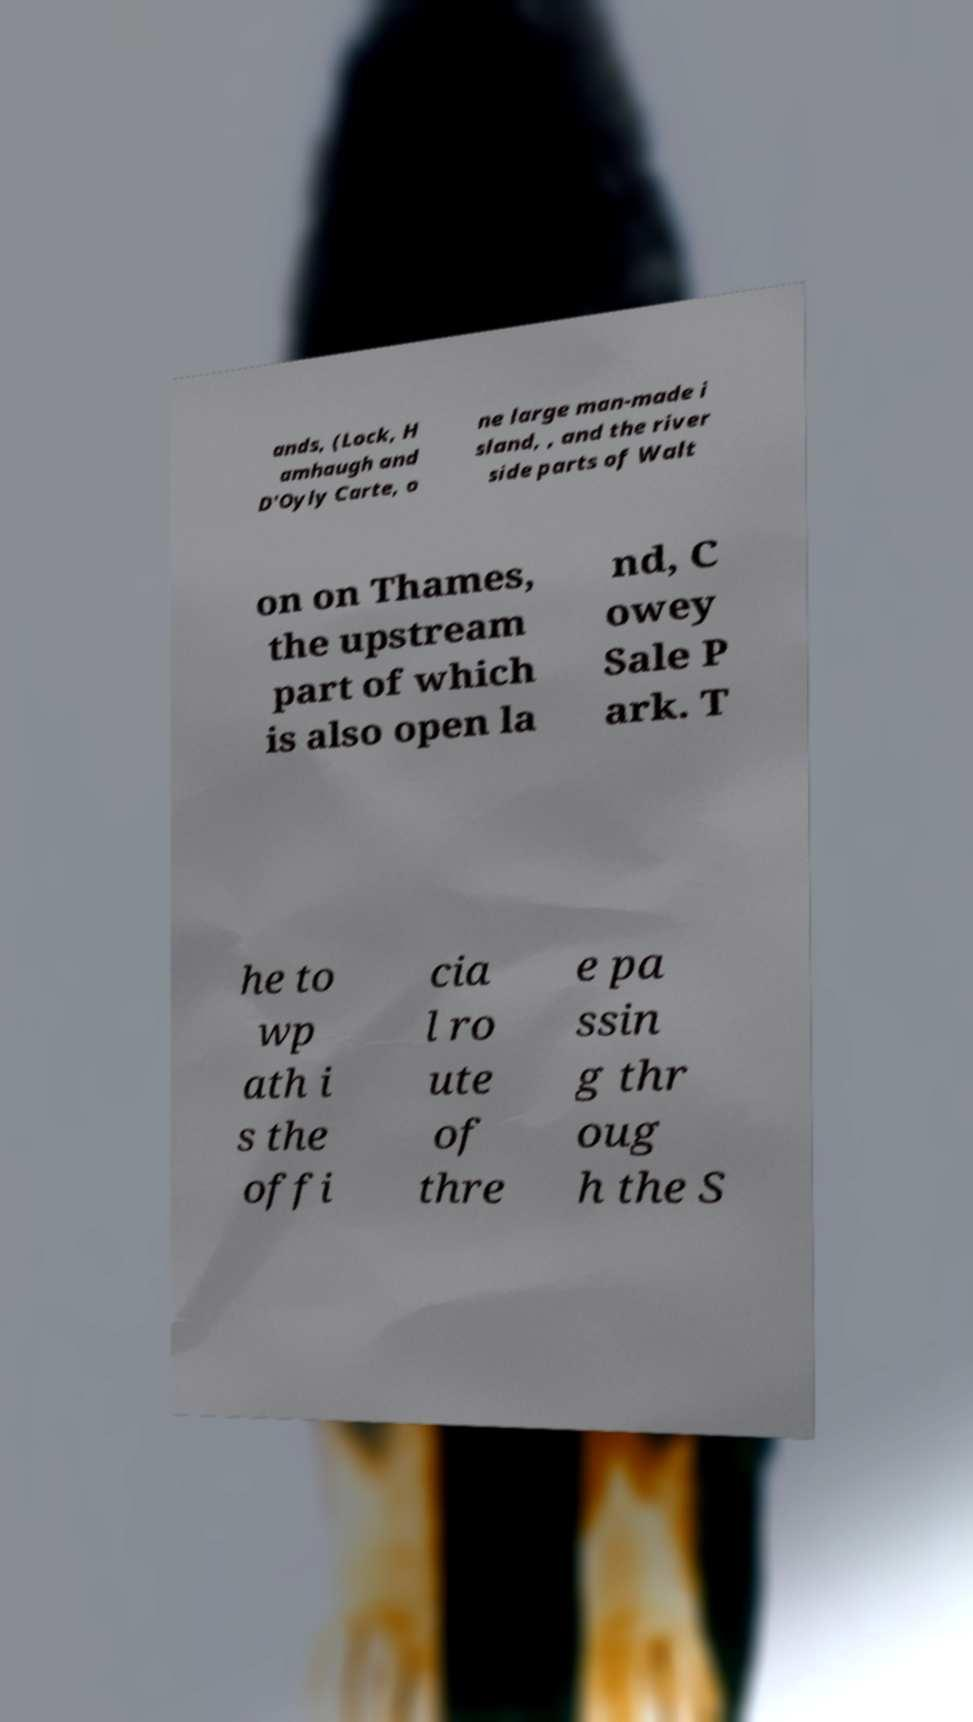For documentation purposes, I need the text within this image transcribed. Could you provide that? ands, (Lock, H amhaugh and D'Oyly Carte, o ne large man-made i sland, , and the river side parts of Walt on on Thames, the upstream part of which is also open la nd, C owey Sale P ark. T he to wp ath i s the offi cia l ro ute of thre e pa ssin g thr oug h the S 